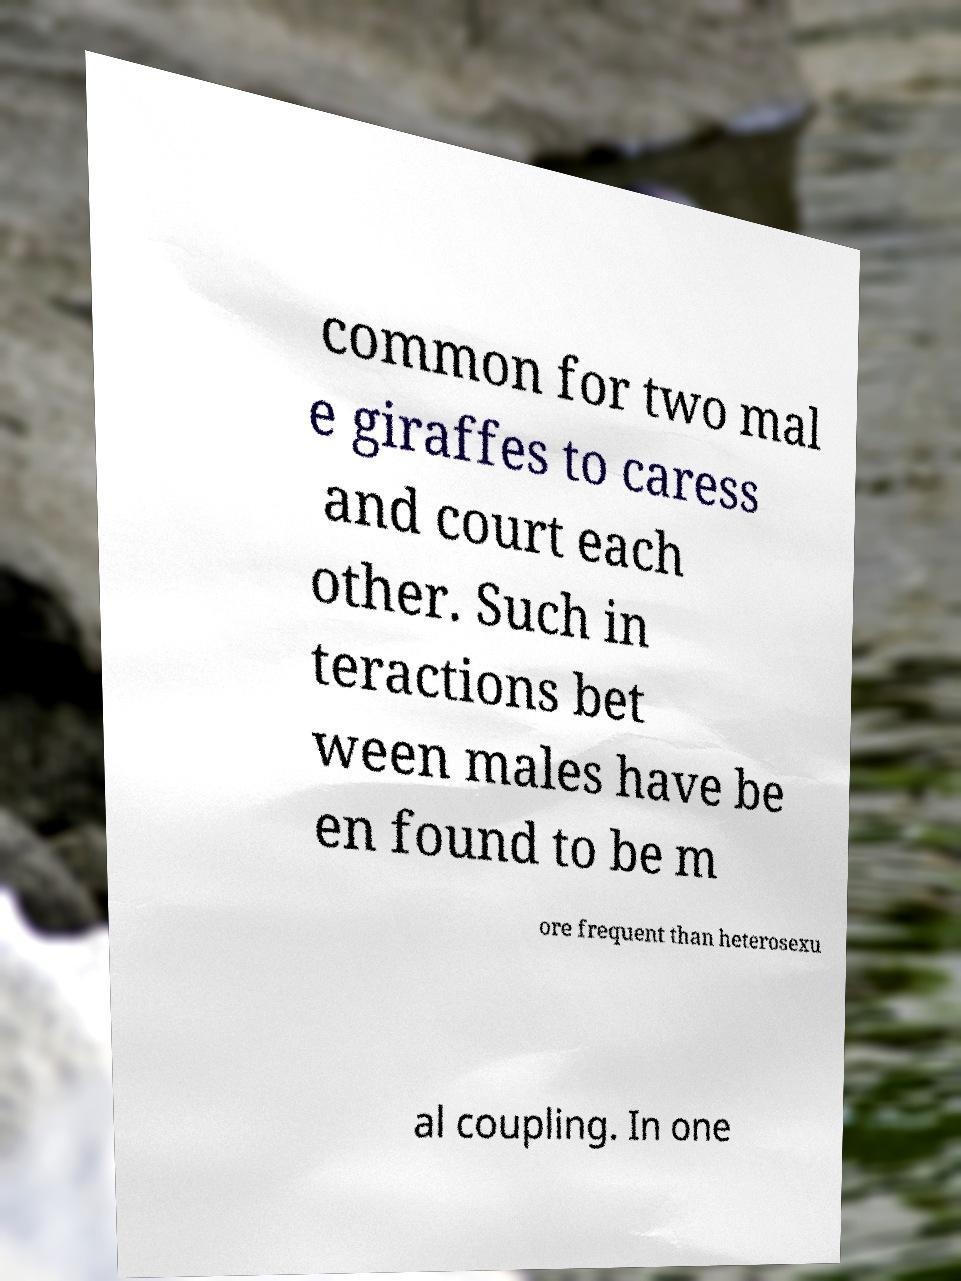Can you read and provide the text displayed in the image?This photo seems to have some interesting text. Can you extract and type it out for me? common for two mal e giraffes to caress and court each other. Such in teractions bet ween males have be en found to be m ore frequent than heterosexu al coupling. In one 